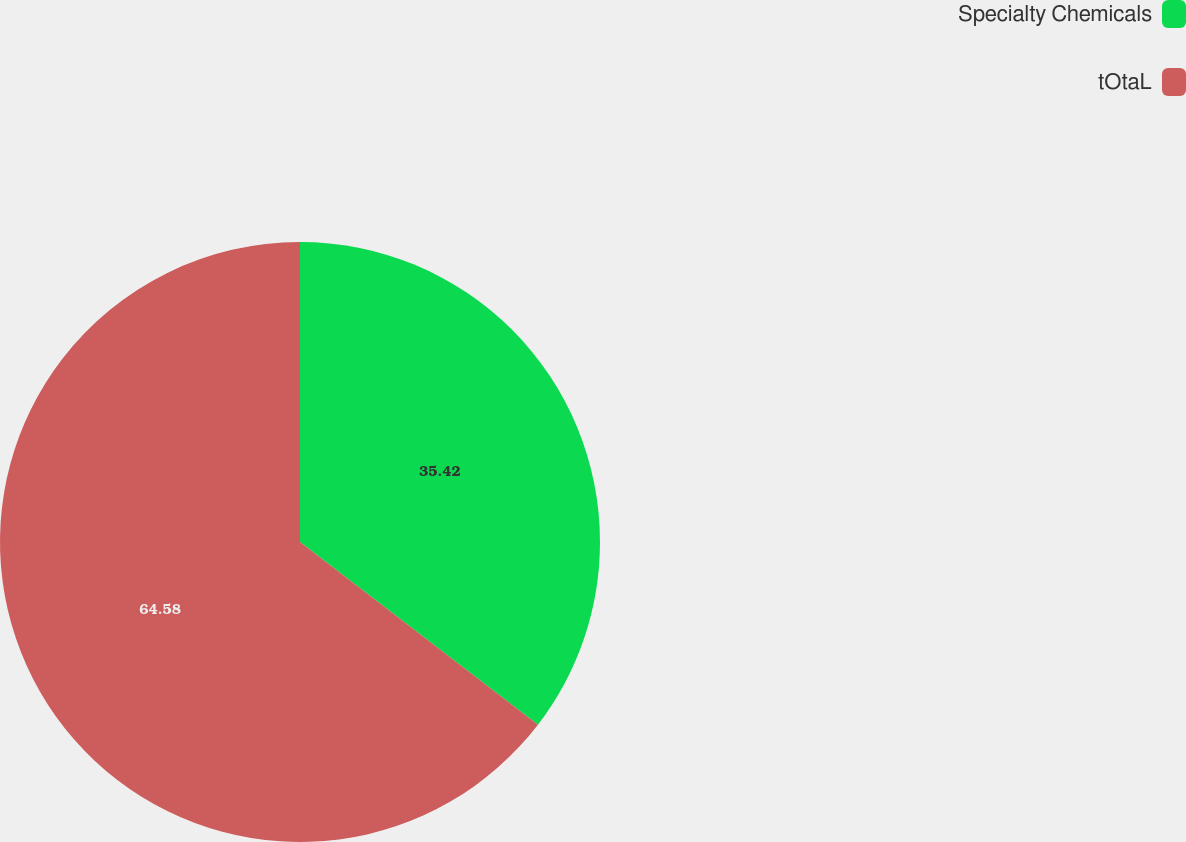Convert chart to OTSL. <chart><loc_0><loc_0><loc_500><loc_500><pie_chart><fcel>Specialty Chemicals<fcel>tOtaL<nl><fcel>35.42%<fcel>64.58%<nl></chart> 